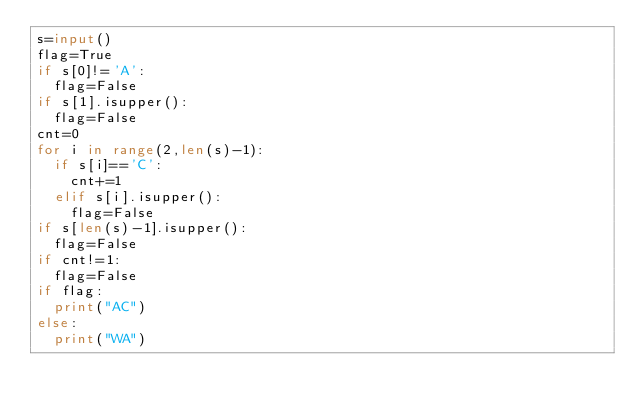Convert code to text. <code><loc_0><loc_0><loc_500><loc_500><_Python_>s=input()
flag=True
if s[0]!='A':
  flag=False
if s[1].isupper():
  flag=False
cnt=0
for i in range(2,len(s)-1):
  if s[i]=='C':
    cnt+=1
  elif s[i].isupper():
    flag=False
if s[len(s)-1].isupper():
  flag=False
if cnt!=1:
  flag=False
if flag:
  print("AC")
else:
  print("WA")  </code> 